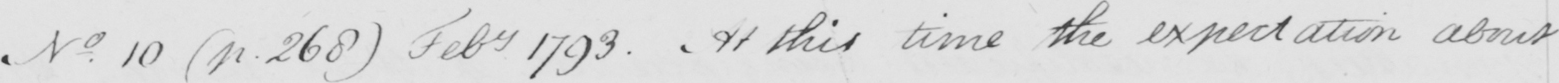Transcribe the text shown in this historical manuscript line. N . 10  ( p . 268 )  Feb 1793 . At this time the expectation about 